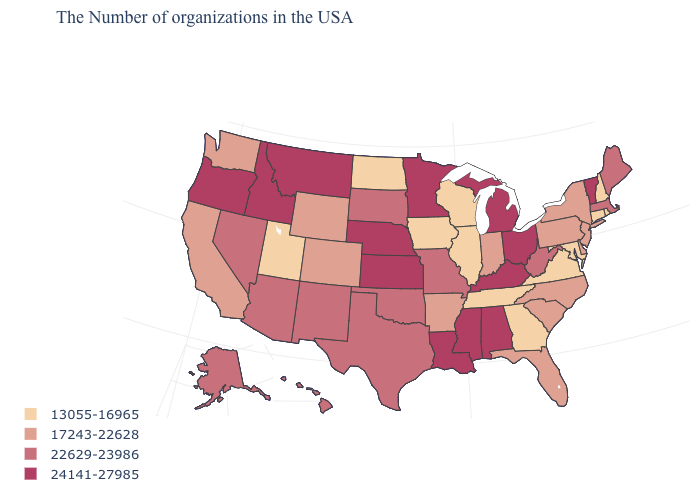Does the map have missing data?
Quick response, please. No. What is the value of California?
Write a very short answer. 17243-22628. What is the value of Minnesota?
Write a very short answer. 24141-27985. How many symbols are there in the legend?
Keep it brief. 4. Does Nevada have the highest value in the USA?
Answer briefly. No. Does Missouri have the same value as Indiana?
Keep it brief. No. Does Illinois have the lowest value in the USA?
Give a very brief answer. Yes. What is the highest value in the West ?
Answer briefly. 24141-27985. What is the highest value in states that border California?
Give a very brief answer. 24141-27985. Name the states that have a value in the range 24141-27985?
Keep it brief. Vermont, Ohio, Michigan, Kentucky, Alabama, Mississippi, Louisiana, Minnesota, Kansas, Nebraska, Montana, Idaho, Oregon. Does Virginia have the same value as Rhode Island?
Write a very short answer. Yes. Name the states that have a value in the range 13055-16965?
Keep it brief. Rhode Island, New Hampshire, Connecticut, Maryland, Virginia, Georgia, Tennessee, Wisconsin, Illinois, Iowa, North Dakota, Utah. Does Maryland have a lower value than Connecticut?
Short answer required. No. What is the value of South Dakota?
Write a very short answer. 22629-23986. Does Iowa have the highest value in the MidWest?
Write a very short answer. No. 